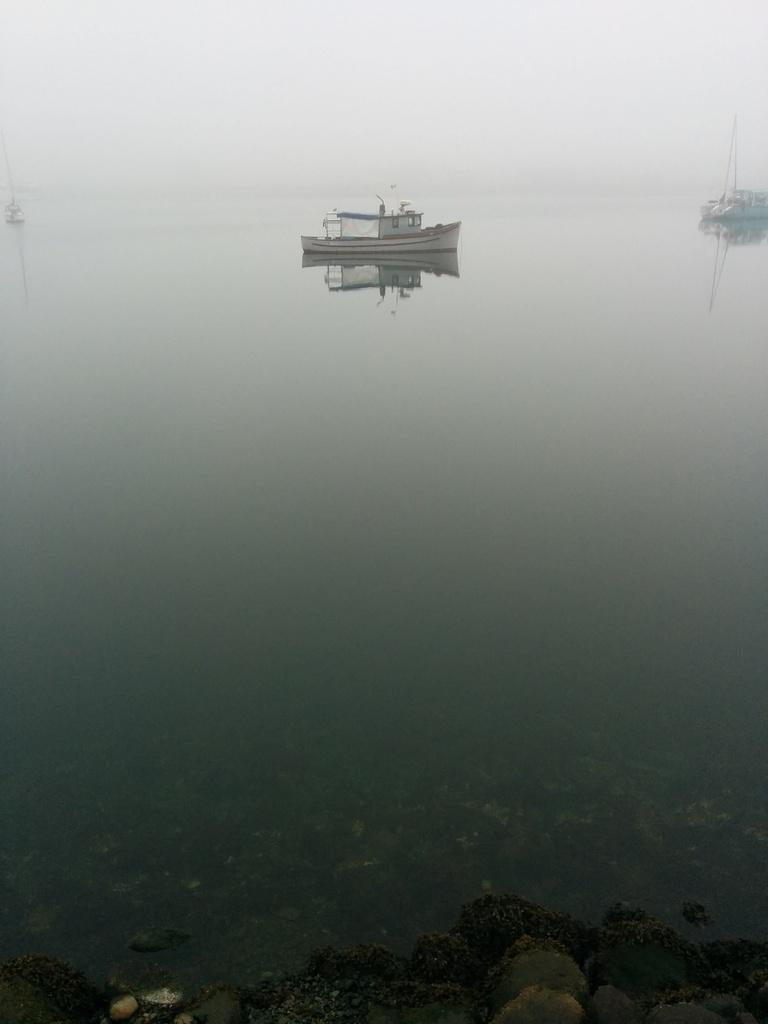What is located above the water in the image? There are boats above the water in the image. What can be seen in the water due to the presence of the boats? The reflection of the boats is visible in the water. What type of rock is being pushed by the cart in the image? There is no rock or cart present in the image; it only features boats and their reflections in the water. 